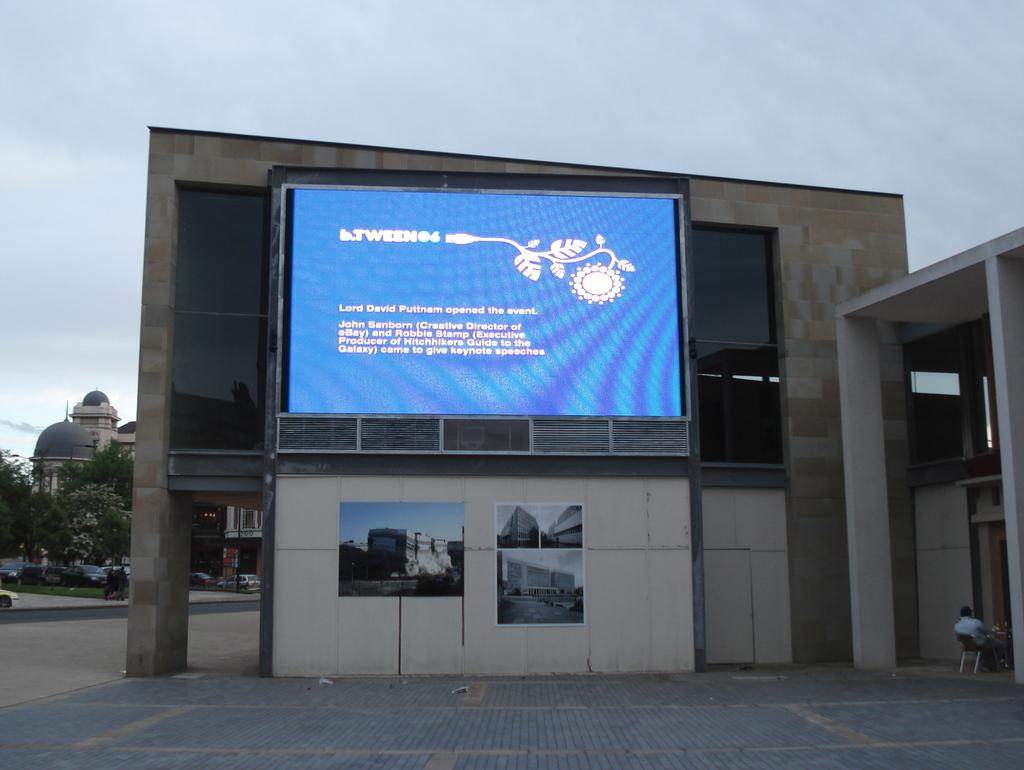What is located on the building in the image? There is a display screen on the building. What can be seen behind the building? There are trees visible behind the building. What else is visible in the background of the image? There are other buildings visible in the background. What type of box is being read by the boot in the image? There is no box or boot present in the image. 